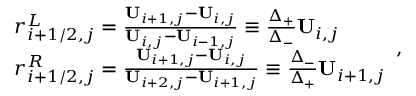Convert formula to latex. <formula><loc_0><loc_0><loc_500><loc_500>\begin{array} { r l } & { r _ { i + 1 / 2 , j } ^ { L } = \frac { U _ { i + 1 , j } - U _ { i , j } } { U _ { i , j } - U _ { i - 1 , j } } \equiv \frac { \Delta _ { + } } { \Delta _ { - } } U _ { i , j } } \\ & { r _ { i + 1 / 2 , j } ^ { R } = \frac { U _ { i + 1 , j } - U _ { i , j } } { U _ { i + 2 , j } - U _ { i + 1 , j } } \equiv \frac { \Delta _ { - } } { \Delta _ { + } } U _ { i + 1 , j } } \end{array} ,</formula> 